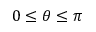Convert formula to latex. <formula><loc_0><loc_0><loc_500><loc_500>0 \leq \theta \leq \pi</formula> 